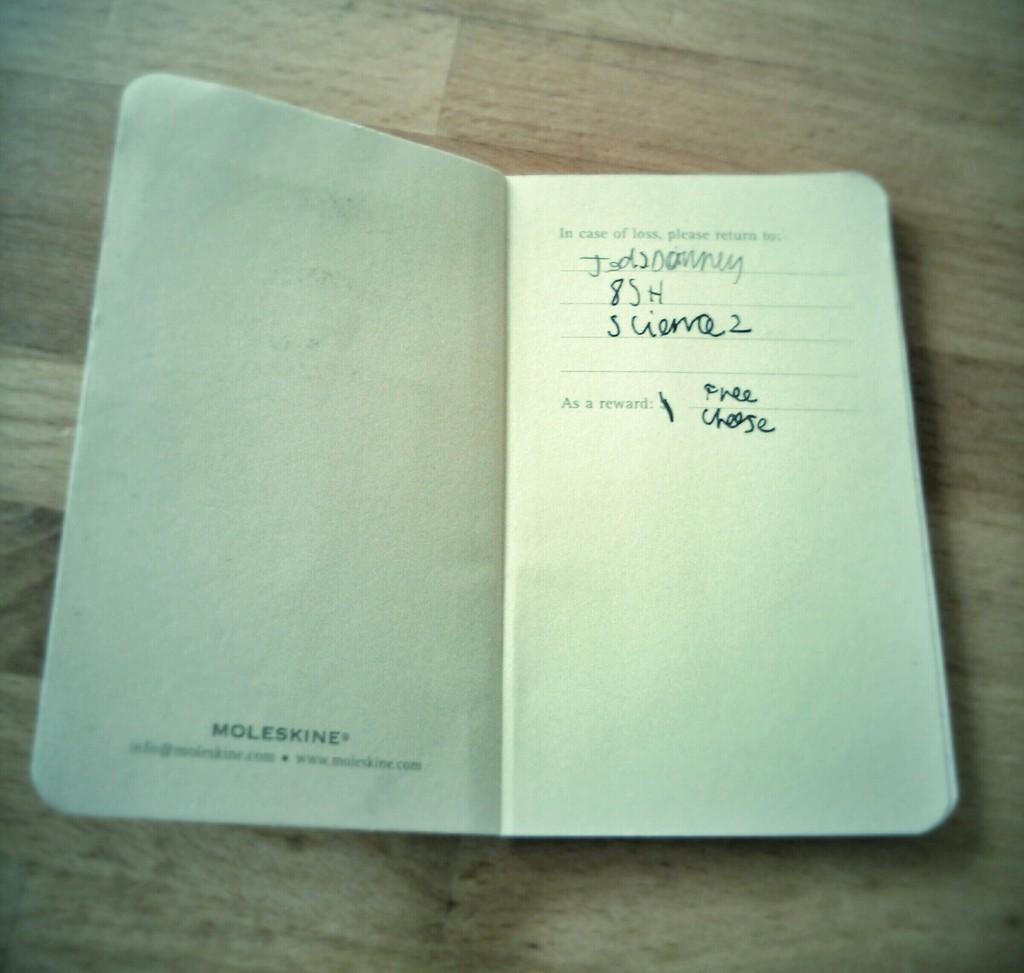<image>
Provide a brief description of the given image. An open diary made by Moleskine on a wooden table. 